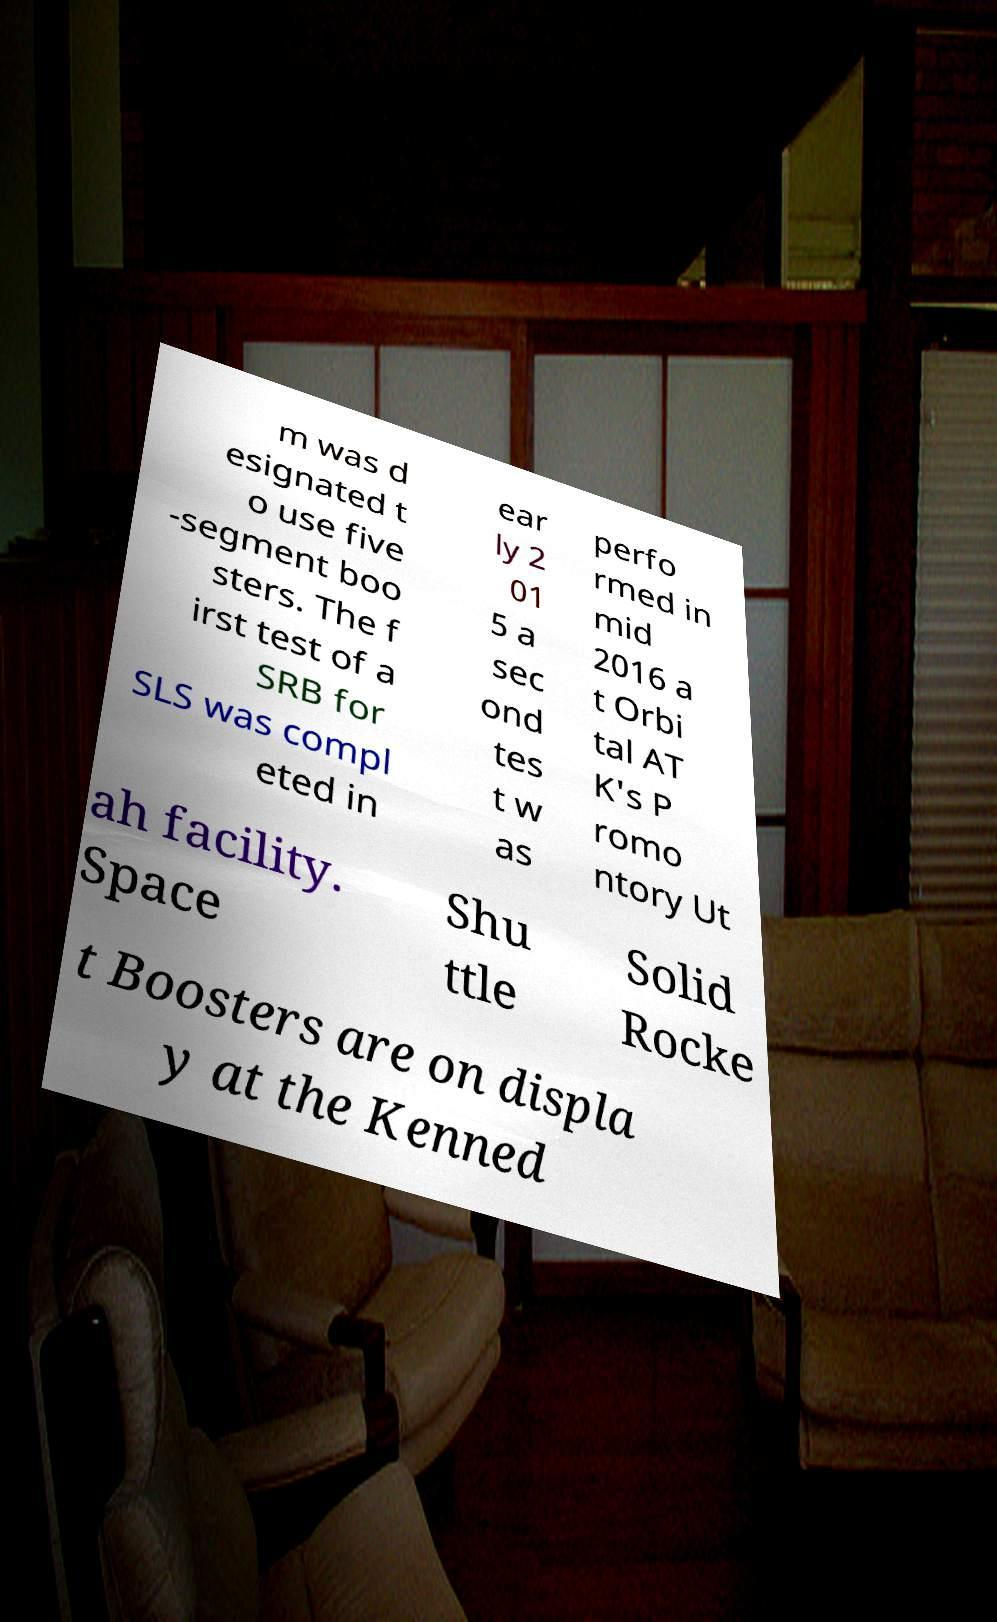For documentation purposes, I need the text within this image transcribed. Could you provide that? m was d esignated t o use five -segment boo sters. The f irst test of a SRB for SLS was compl eted in ear ly 2 01 5 a sec ond tes t w as perfo rmed in mid 2016 a t Orbi tal AT K's P romo ntory Ut ah facility. Space Shu ttle Solid Rocke t Boosters are on displa y at the Kenned 